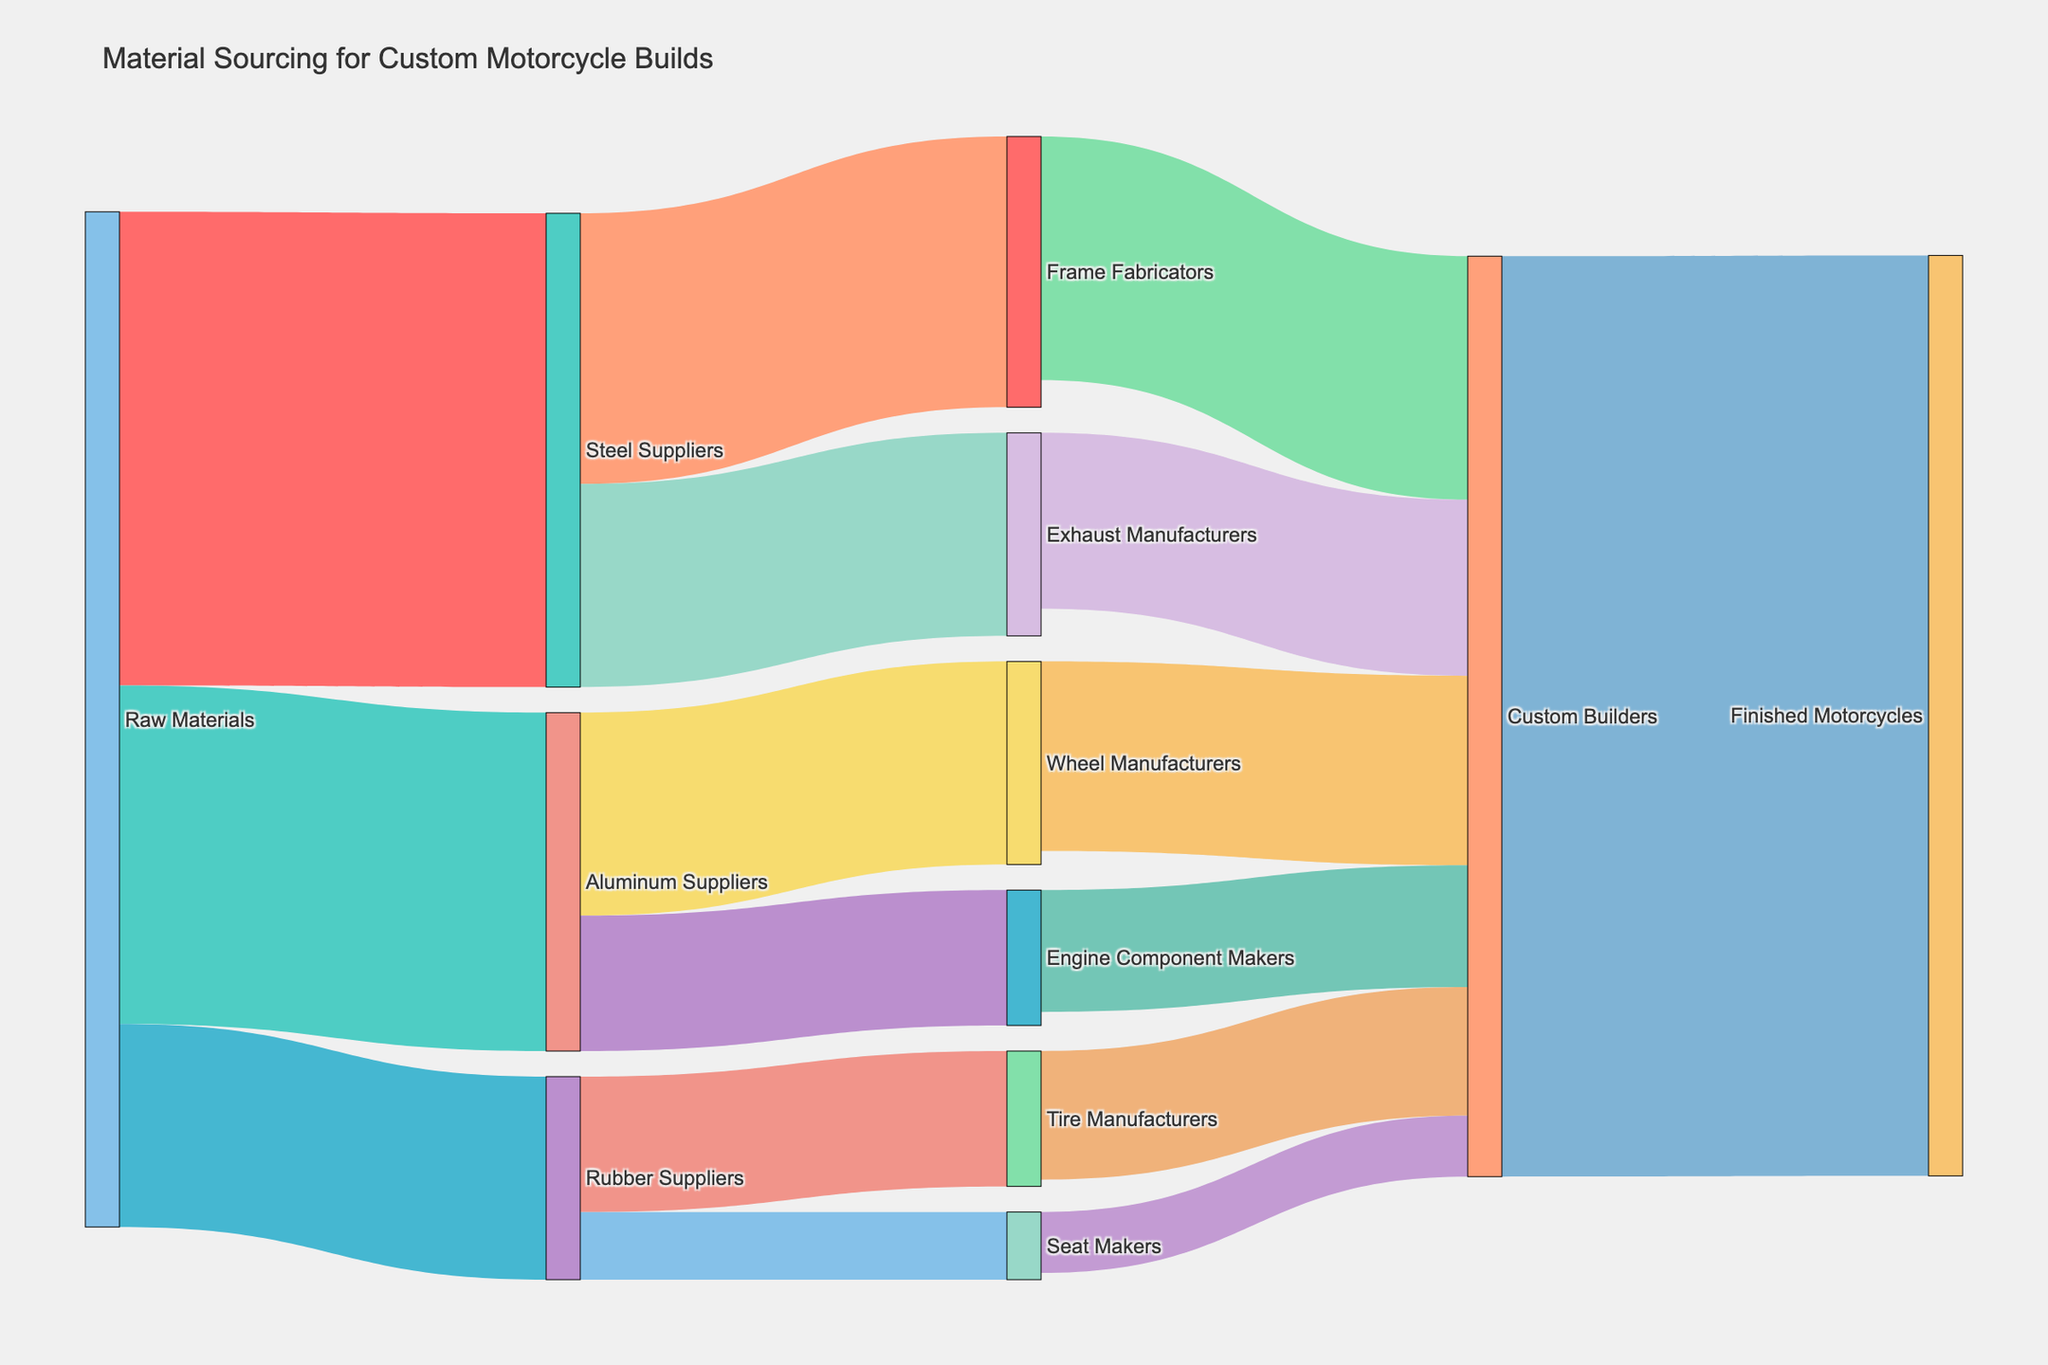What is the title of the diagram? The title of a plot is typically located at the top and provides a summary of what the diagram represents. In this case, the title "Material Sourcing for Custom Motorcycle Builds" explains what the Sankey Diagram is about.
Answer: Material Sourcing for Custom Motorcycle Builds How many distinct raw material suppliers are shown in the diagram? The figure shows three distinct raw material suppliers: Steel Suppliers, Aluminum Suppliers, and Rubber Suppliers, which are directly connected to the "Raw Materials" node.
Answer: 3 Which supplier provides the most material to Custom Builders? By checking the total value of materials provided to Custom Builders, we see that Frame Fabricators provide 180 units, Exhaust Manufacturers provide 130 units, Wheel Manufacturers provide 140 units, Engine Component Makers provide 90 units, Tire Manufacturers provide 95 units, and Seat Makers provide 45 units. Frame Fabricators provide the most.
Answer: Frame Fabricators How many units of rubber go to Tire Manufacturers? Following the link from Rubber Suppliers to Tire Manufacturers, we see that it carries a value of 100 units.
Answer: 100 What is the total material received by Custom Builders from all suppliers? To find the total material received by Custom Builders, sum the values from all suppliers to Custom Builders: 180 (Frame Fabricators) + 130 (Exhaust Manufacturers) + 140 (Wheel Manufacturers) + 90 (Engine Component Makers) + 95 (Tire Manufacturers) + 45 (Seat Makers). The total is 680 units.
Answer: 680 Compare the amount of material Rubber Suppliers provide to Seat Makers versus Tire Manufacturers. Rubber Suppliers provide 50 units to Seat Makers and 100 units to Tire Manufacturers. Tire Manufacturers receive twice as much material as Seat Makers.
Answer: Tire Manufacturers receive more What is the combined material flow from Raw Materials to Steel Suppliers and Aluminum Suppliers? Raw Materials send 350 units to Steel Suppliers and 250 units to Aluminum Suppliers. Combined, this totals 350 + 250 = 600 units.
Answer: 600 Which node directly connects to the Finished Motorcycles node? The Finished Motorcycles node is only directly linked from Custom Builders.
Answer: Custom Builders 